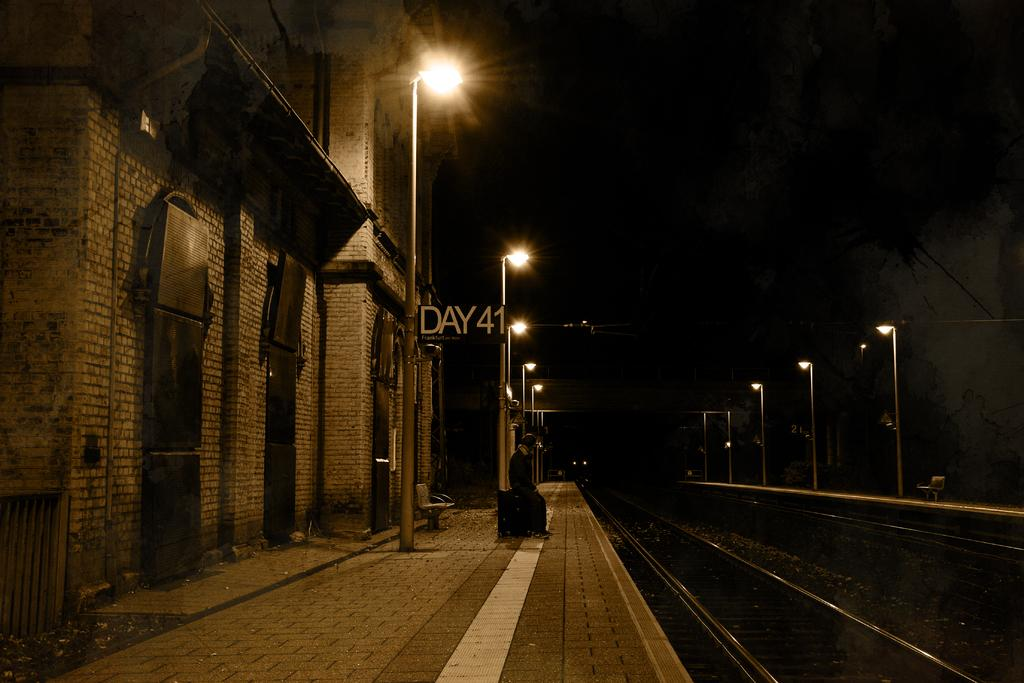Provide a one-sentence caption for the provided image. The sign at the train tracks says Day 41. 